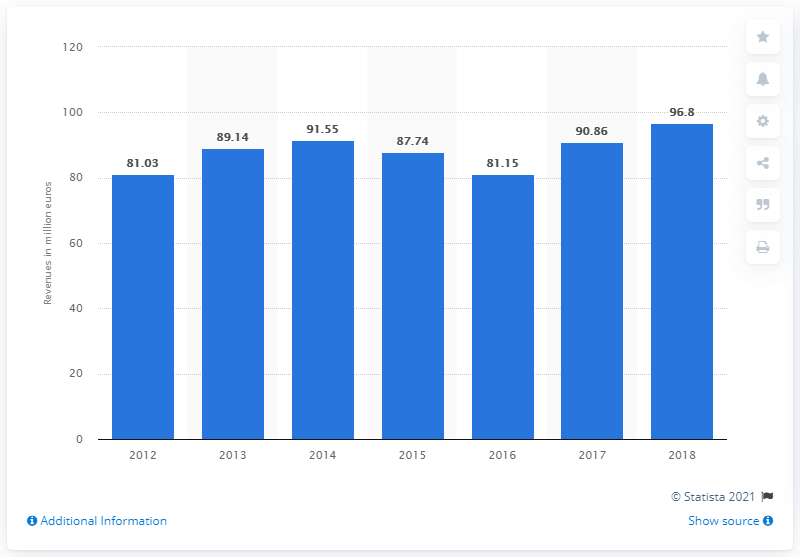Outline some significant characteristics in this image. In 2017, the turnover of Ermenegildo Zegna Holditalia S.p.A. was 96.8. Ermenegildo Zegna Holditalia SpA's turnover increased by 96.8% in 2017. 